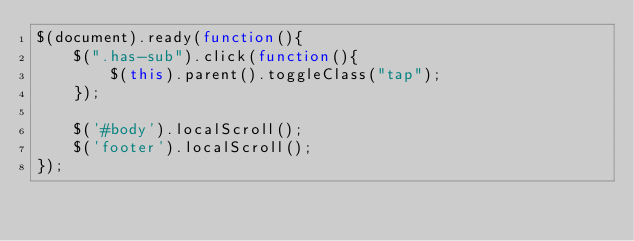Convert code to text. <code><loc_0><loc_0><loc_500><loc_500><_JavaScript_>$(document).ready(function(){
    $(".has-sub").click(function(){
        $(this).parent().toggleClass("tap");
    });

    $('#body').localScroll();
    $('footer').localScroll();
});
</code> 